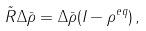Convert formula to latex. <formula><loc_0><loc_0><loc_500><loc_500>\tilde { R } \Delta \bar { \rho } = \Delta \bar { \rho } ( I - \rho ^ { e q } ) \, ,</formula> 